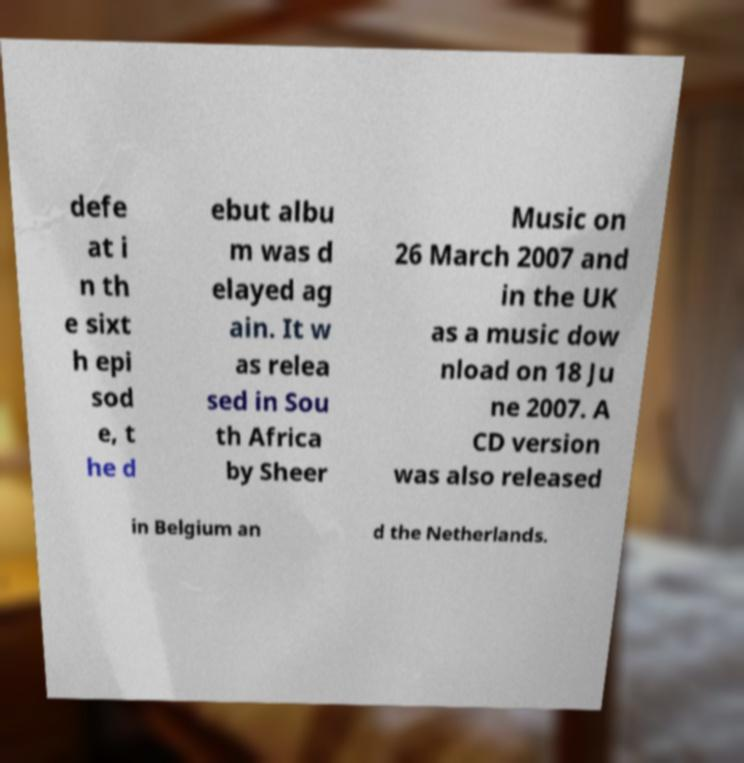Please identify and transcribe the text found in this image. defe at i n th e sixt h epi sod e, t he d ebut albu m was d elayed ag ain. It w as relea sed in Sou th Africa by Sheer Music on 26 March 2007 and in the UK as a music dow nload on 18 Ju ne 2007. A CD version was also released in Belgium an d the Netherlands. 